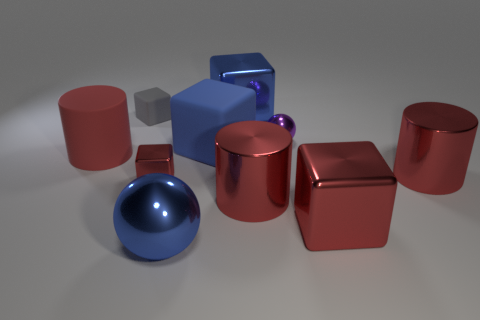How many objects are small shiny things in front of the red matte cylinder or small shiny things that are in front of the purple metallic object?
Your response must be concise. 1. Is there anything else that is the same shape as the tiny red metal object?
Provide a succinct answer. Yes. There is a metallic ball that is behind the large red matte object; does it have the same color as the metal sphere that is in front of the large red rubber thing?
Your response must be concise. No. What number of rubber objects are large blue spheres or cubes?
Give a very brief answer. 2. What is the shape of the large thing that is right of the large metal block in front of the blue rubber block?
Offer a terse response. Cylinder. Does the cylinder on the left side of the tiny red object have the same material as the tiny gray cube that is left of the big ball?
Keep it short and to the point. Yes. There is a big metallic block that is behind the tiny matte object; how many red objects are to the right of it?
Your answer should be compact. 3. Does the big blue object that is behind the purple ball have the same shape as the big rubber object that is on the right side of the gray matte thing?
Provide a succinct answer. Yes. How big is the shiny cube that is in front of the gray cube and left of the tiny shiny sphere?
Provide a short and direct response. Small. What color is the small shiny object that is the same shape as the tiny rubber object?
Provide a succinct answer. Red. 